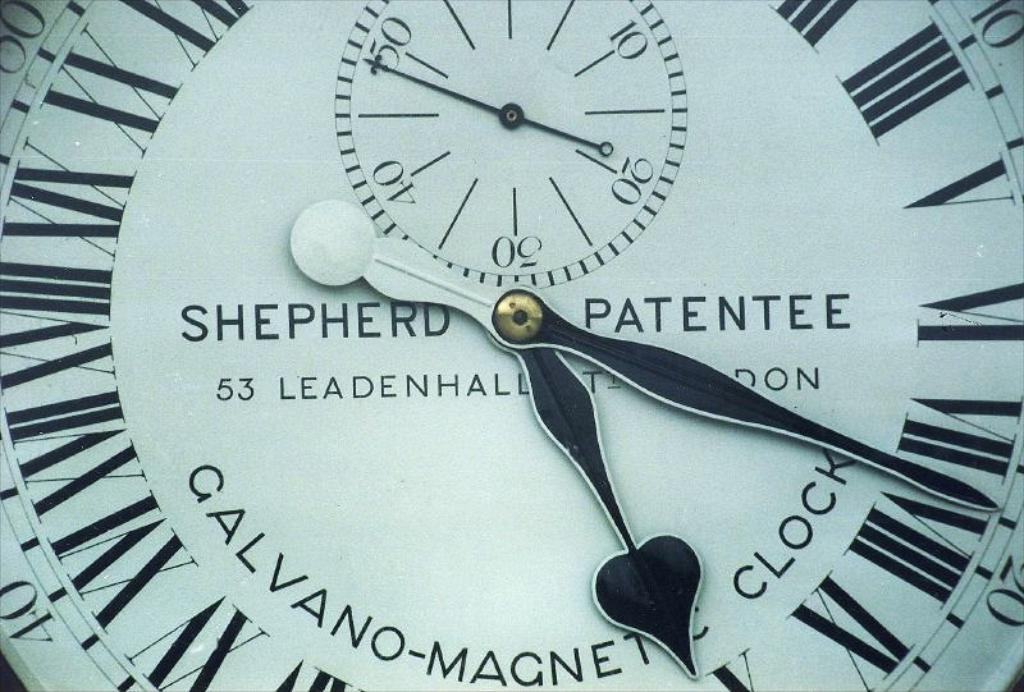Provide a one-sentence caption for the provided image. The beautiful clock face shown was made by Shepherd Patentee. 